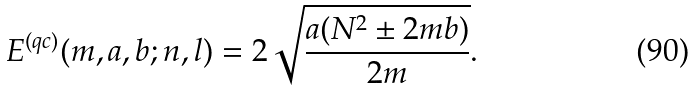Convert formula to latex. <formula><loc_0><loc_0><loc_500><loc_500>E ^ { ( q c ) } ( m , a , b ; n , l ) = 2 \sqrt { \frac { a ( N ^ { 2 } \pm 2 m b ) } { 2 m } } .</formula> 